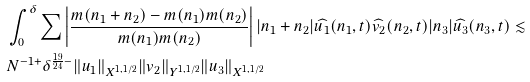<formula> <loc_0><loc_0><loc_500><loc_500>& \int _ { 0 } ^ { \delta } \sum \left | \frac { m ( n _ { 1 } + n _ { 2 } ) - m ( n _ { 1 } ) m ( n _ { 2 } ) } { m ( n _ { 1 } ) m ( n _ { 2 } ) } \right | | n _ { 1 } + n _ { 2 } | \widehat { u _ { 1 } } ( n _ { 1 } , t ) \widehat { v _ { 2 } } ( n _ { 2 } , t ) | n _ { 3 } | \widehat { u _ { 3 } } ( n _ { 3 } , t ) \lesssim \\ & N ^ { - 1 + } \delta ^ { \frac { 1 9 } { 2 4 } - } \| u _ { 1 } \| _ { X ^ { 1 , 1 / 2 } } \| v _ { 2 } \| _ { Y ^ { 1 , 1 / 2 } } \| u _ { 3 } \| _ { X ^ { 1 , 1 / 2 } }</formula> 